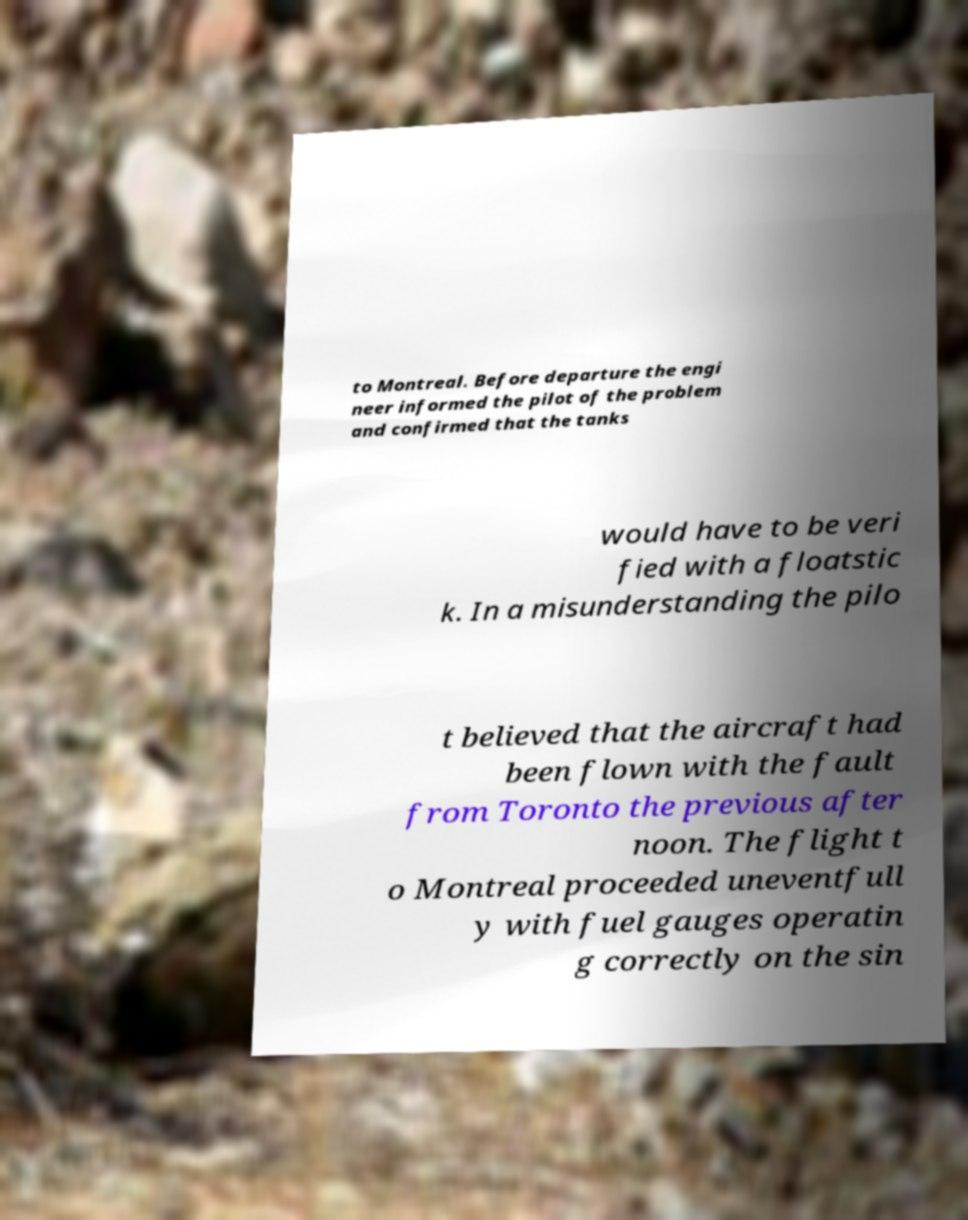For documentation purposes, I need the text within this image transcribed. Could you provide that? to Montreal. Before departure the engi neer informed the pilot of the problem and confirmed that the tanks would have to be veri fied with a floatstic k. In a misunderstanding the pilo t believed that the aircraft had been flown with the fault from Toronto the previous after noon. The flight t o Montreal proceeded uneventfull y with fuel gauges operatin g correctly on the sin 